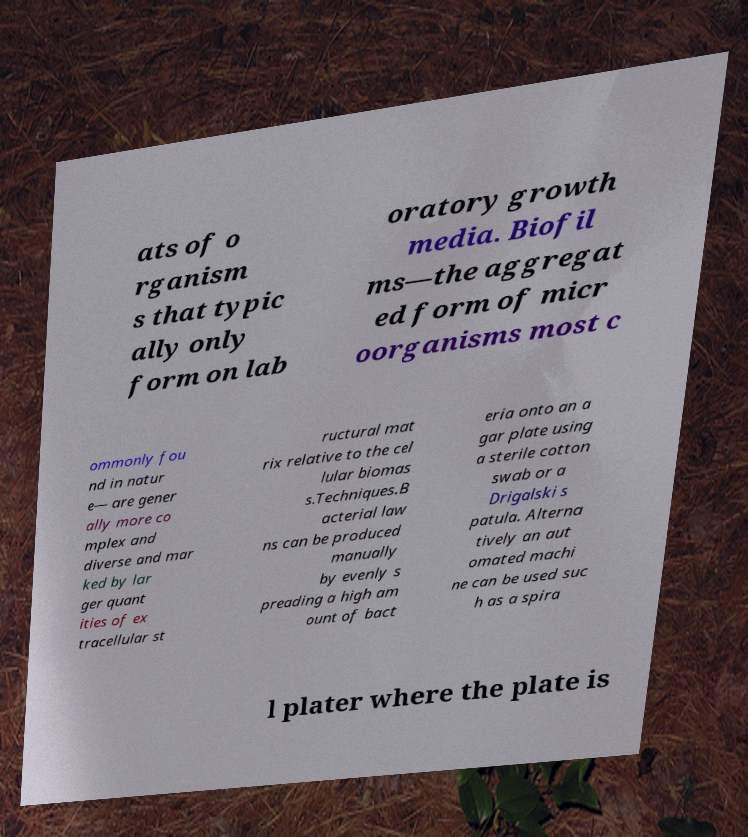Can you accurately transcribe the text from the provided image for me? ats of o rganism s that typic ally only form on lab oratory growth media. Biofil ms—the aggregat ed form of micr oorganisms most c ommonly fou nd in natur e— are gener ally more co mplex and diverse and mar ked by lar ger quant ities of ex tracellular st ructural mat rix relative to the cel lular biomas s.Techniques.B acterial law ns can be produced manually by evenly s preading a high am ount of bact eria onto an a gar plate using a sterile cotton swab or a Drigalski s patula. Alterna tively an aut omated machi ne can be used suc h as a spira l plater where the plate is 